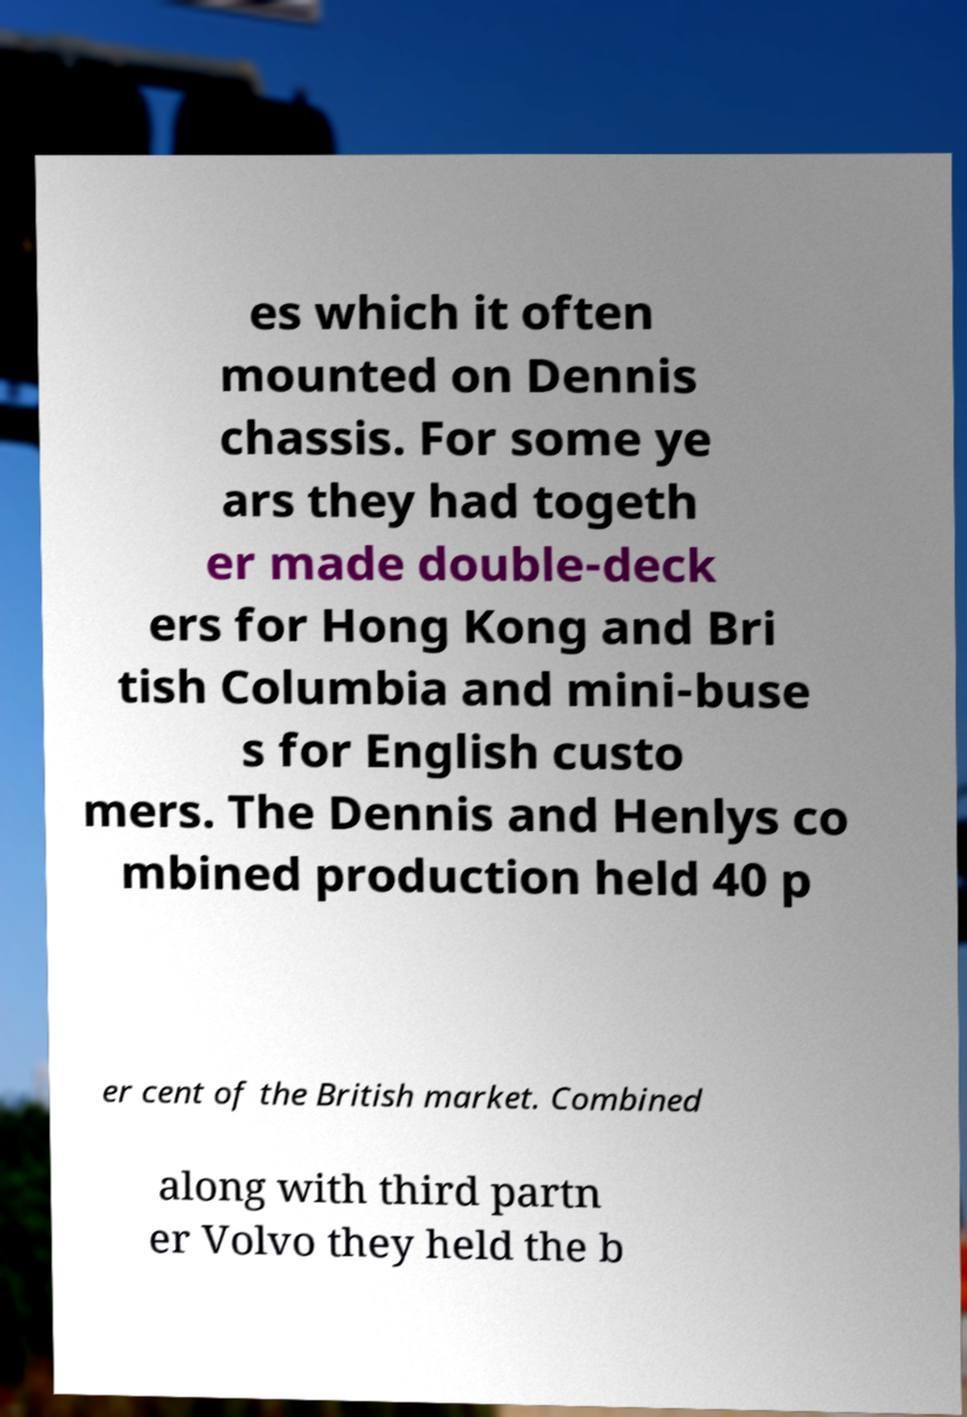For documentation purposes, I need the text within this image transcribed. Could you provide that? es which it often mounted on Dennis chassis. For some ye ars they had togeth er made double-deck ers for Hong Kong and Bri tish Columbia and mini-buse s for English custo mers. The Dennis and Henlys co mbined production held 40 p er cent of the British market. Combined along with third partn er Volvo they held the b 